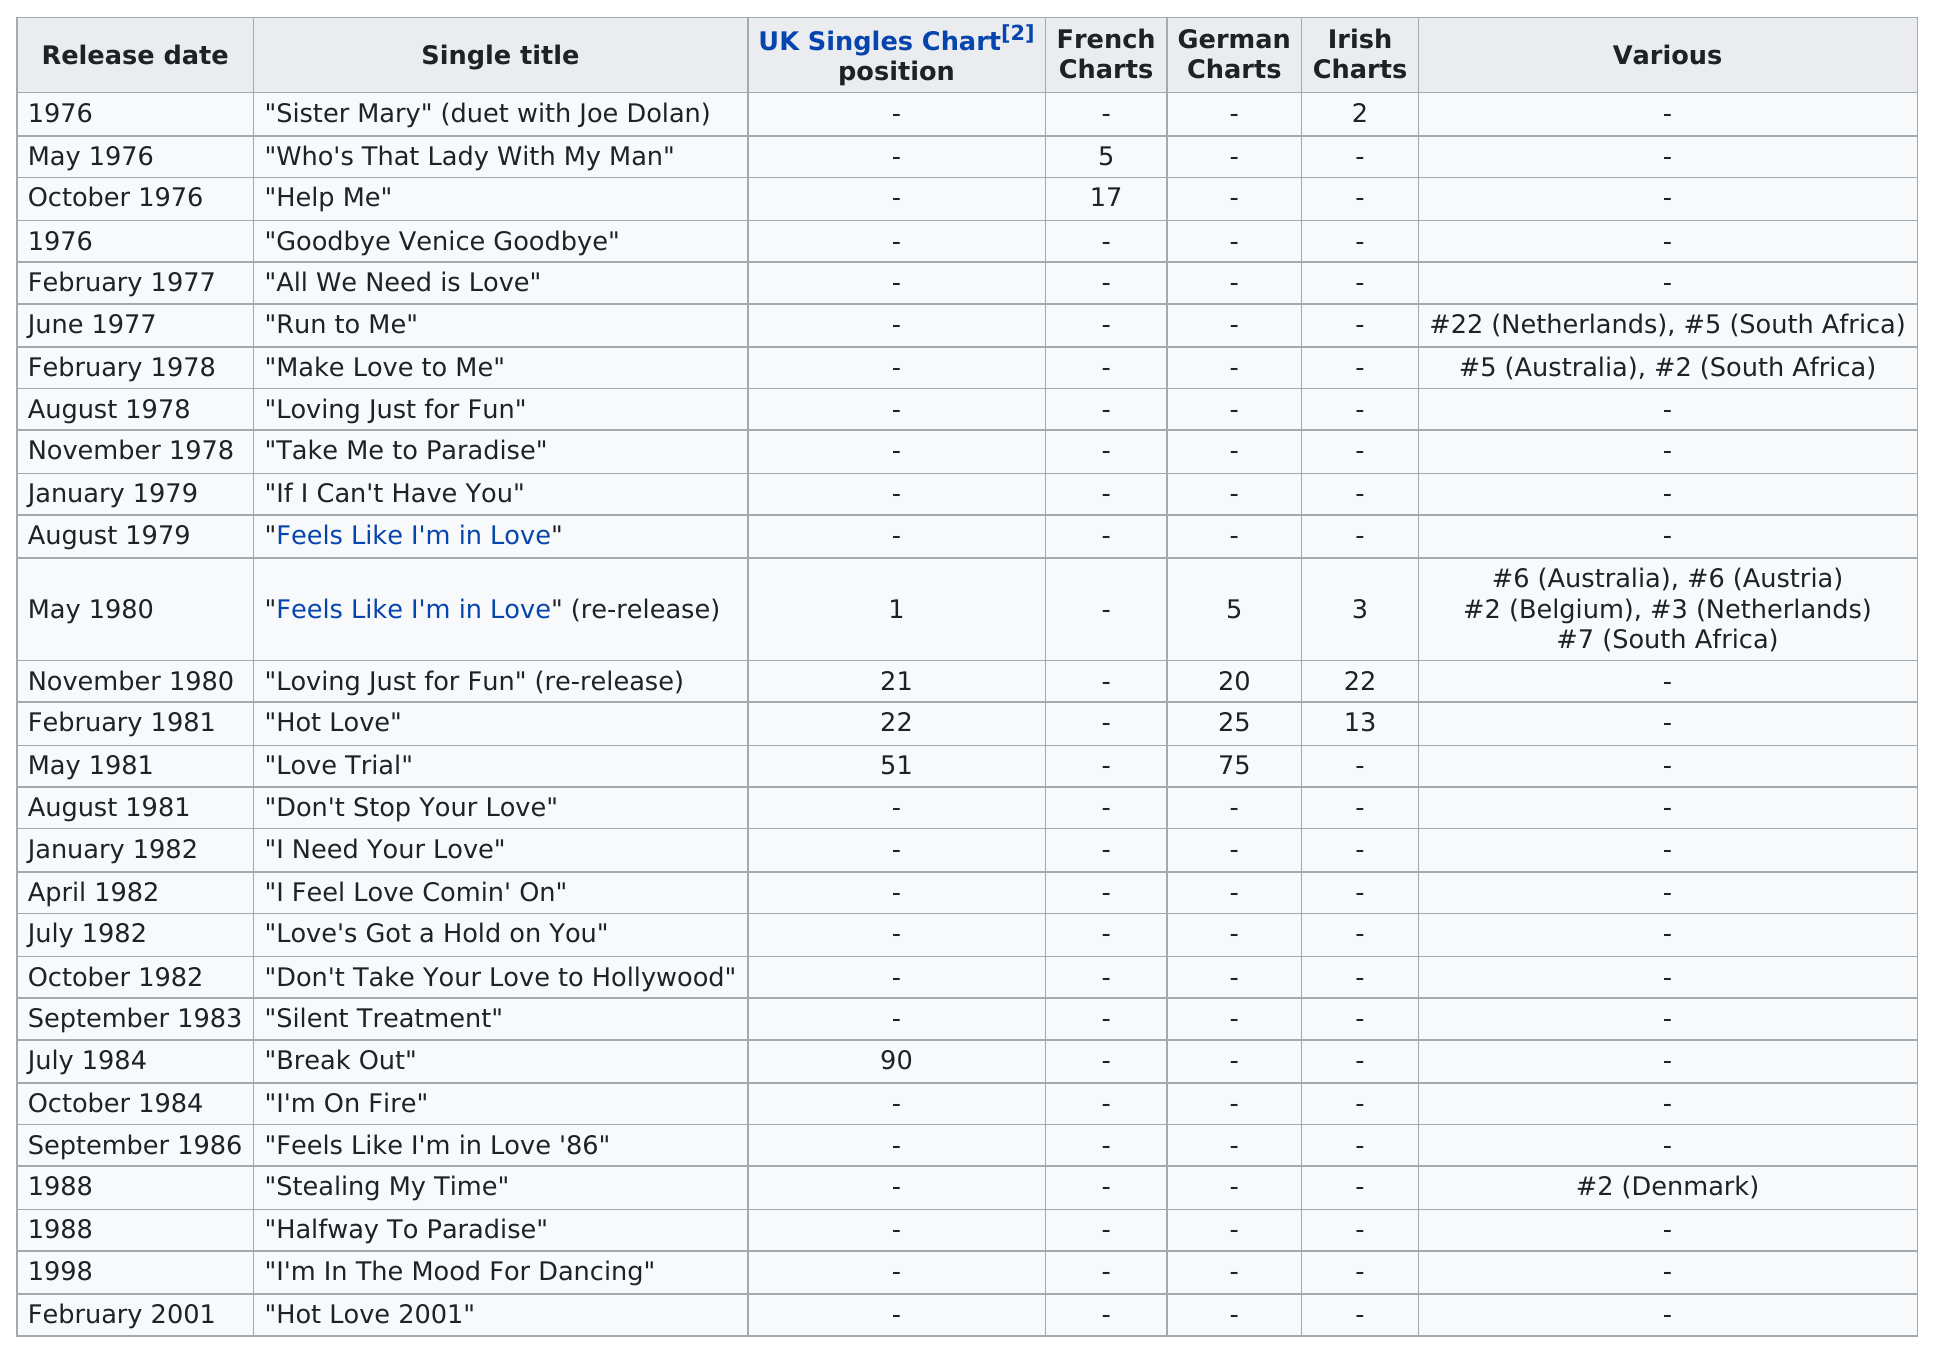Draw attention to some important aspects in this diagram. The first single by Kelly Marie was released in the year 1976. There were a total of three songs that charted on the UK Singles Chart and reached a position of at least 50th or higher. The song 'Sister Mary' was released earlier than 'Run to Me'. In 1976, Kelly Marie released four songs. The single title that is currently listed on the French charts after "Who's That Lady With My Man"? "Help Me". 